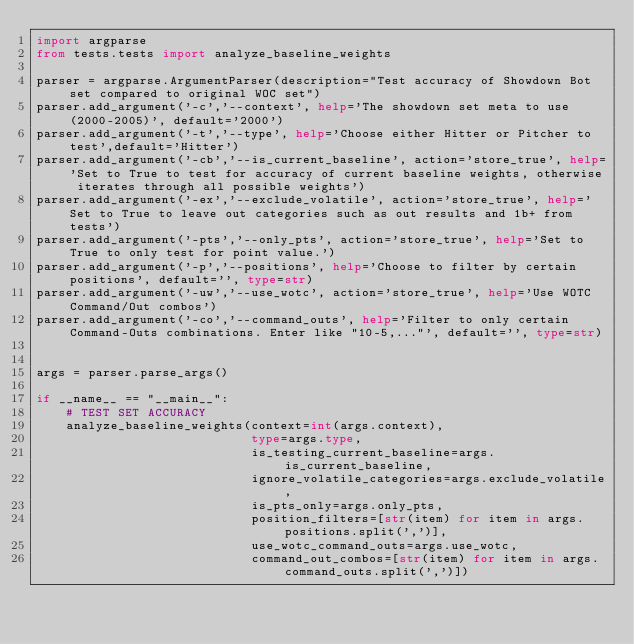<code> <loc_0><loc_0><loc_500><loc_500><_Python_>import argparse
from tests.tests import analyze_baseline_weights

parser = argparse.ArgumentParser(description="Test accuracy of Showdown Bot set compared to original WOC set")
parser.add_argument('-c','--context', help='The showdown set meta to use (2000-2005)', default='2000')
parser.add_argument('-t','--type', help='Choose either Hitter or Pitcher to test',default='Hitter')
parser.add_argument('-cb','--is_current_baseline', action='store_true', help='Set to True to test for accuracy of current baseline weights, otherwise iterates through all possible weights')
parser.add_argument('-ex','--exclude_volatile', action='store_true', help='Set to True to leave out categories such as out results and 1b+ from tests')
parser.add_argument('-pts','--only_pts', action='store_true', help='Set to True to only test for point value.')
parser.add_argument('-p','--positions', help='Choose to filter by certain positions', default='', type=str)
parser.add_argument('-uw','--use_wotc', action='store_true', help='Use WOTC Command/Out combos')
parser.add_argument('-co','--command_outs', help='Filter to only certain Command-Outs combinations. Enter like "10-5,..."', default='', type=str)


args = parser.parse_args()

if __name__ == "__main__":
    # TEST SET ACCURACY
    analyze_baseline_weights(context=int(args.context), 
                             type=args.type, 
                             is_testing_current_baseline=args.is_current_baseline,
                             ignore_volatile_categories=args.exclude_volatile,
                             is_pts_only=args.only_pts,
                             position_filters=[str(item) for item in args.positions.split(',')],
                             use_wotc_command_outs=args.use_wotc,
                             command_out_combos=[str(item) for item in args.command_outs.split(',')])</code> 